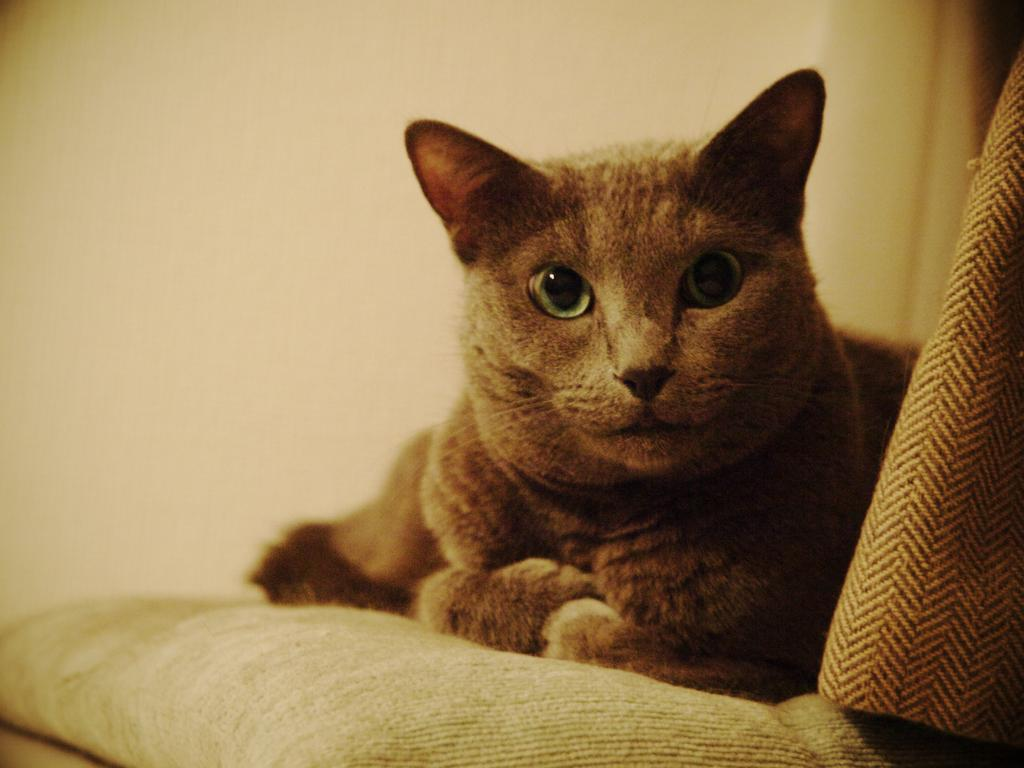What animal is present in the image? There is a cat in the image. Where is the cat located? The cat is on a surface in the image. What can be seen behind the cat? There is a wall behind the cat in the image. How many rabbits are hopping around the cat in the image? There are no rabbits present in the image; it only features a cat. 